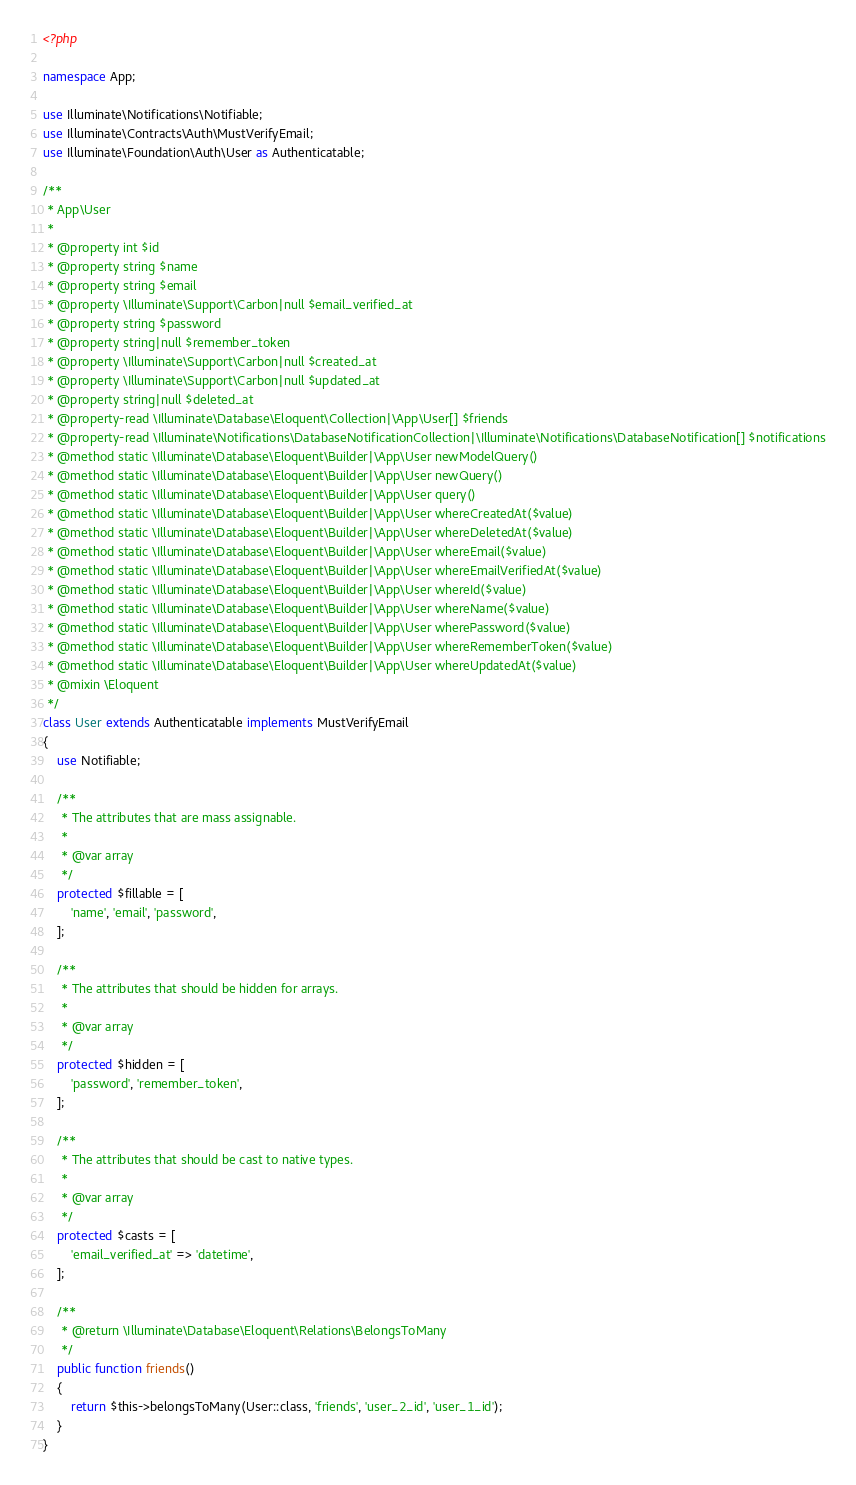<code> <loc_0><loc_0><loc_500><loc_500><_PHP_><?php

namespace App;

use Illuminate\Notifications\Notifiable;
use Illuminate\Contracts\Auth\MustVerifyEmail;
use Illuminate\Foundation\Auth\User as Authenticatable;

/**
 * App\User
 *
 * @property int $id
 * @property string $name
 * @property string $email
 * @property \Illuminate\Support\Carbon|null $email_verified_at
 * @property string $password
 * @property string|null $remember_token
 * @property \Illuminate\Support\Carbon|null $created_at
 * @property \Illuminate\Support\Carbon|null $updated_at
 * @property string|null $deleted_at
 * @property-read \Illuminate\Database\Eloquent\Collection|\App\User[] $friends
 * @property-read \Illuminate\Notifications\DatabaseNotificationCollection|\Illuminate\Notifications\DatabaseNotification[] $notifications
 * @method static \Illuminate\Database\Eloquent\Builder|\App\User newModelQuery()
 * @method static \Illuminate\Database\Eloquent\Builder|\App\User newQuery()
 * @method static \Illuminate\Database\Eloquent\Builder|\App\User query()
 * @method static \Illuminate\Database\Eloquent\Builder|\App\User whereCreatedAt($value)
 * @method static \Illuminate\Database\Eloquent\Builder|\App\User whereDeletedAt($value)
 * @method static \Illuminate\Database\Eloquent\Builder|\App\User whereEmail($value)
 * @method static \Illuminate\Database\Eloquent\Builder|\App\User whereEmailVerifiedAt($value)
 * @method static \Illuminate\Database\Eloquent\Builder|\App\User whereId($value)
 * @method static \Illuminate\Database\Eloquent\Builder|\App\User whereName($value)
 * @method static \Illuminate\Database\Eloquent\Builder|\App\User wherePassword($value)
 * @method static \Illuminate\Database\Eloquent\Builder|\App\User whereRememberToken($value)
 * @method static \Illuminate\Database\Eloquent\Builder|\App\User whereUpdatedAt($value)
 * @mixin \Eloquent
 */
class User extends Authenticatable implements MustVerifyEmail
{
    use Notifiable;

    /**
     * The attributes that are mass assignable.
     *
     * @var array
     */
    protected $fillable = [
        'name', 'email', 'password',
    ];

    /**
     * The attributes that should be hidden for arrays.
     *
     * @var array
     */
    protected $hidden = [
        'password', 'remember_token',
    ];

    /**
     * The attributes that should be cast to native types.
     *
     * @var array
     */
    protected $casts = [
        'email_verified_at' => 'datetime',
    ];

    /**
     * @return \Illuminate\Database\Eloquent\Relations\BelongsToMany
     */
    public function friends()
    {
        return $this->belongsToMany(User::class, 'friends', 'user_2_id', 'user_1_id');
    }
}
</code> 